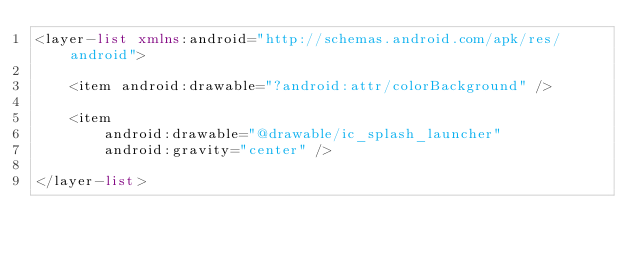Convert code to text. <code><loc_0><loc_0><loc_500><loc_500><_XML_><layer-list xmlns:android="http://schemas.android.com/apk/res/android">

    <item android:drawable="?android:attr/colorBackground" />

    <item
        android:drawable="@drawable/ic_splash_launcher"
        android:gravity="center" />

</layer-list>
</code> 